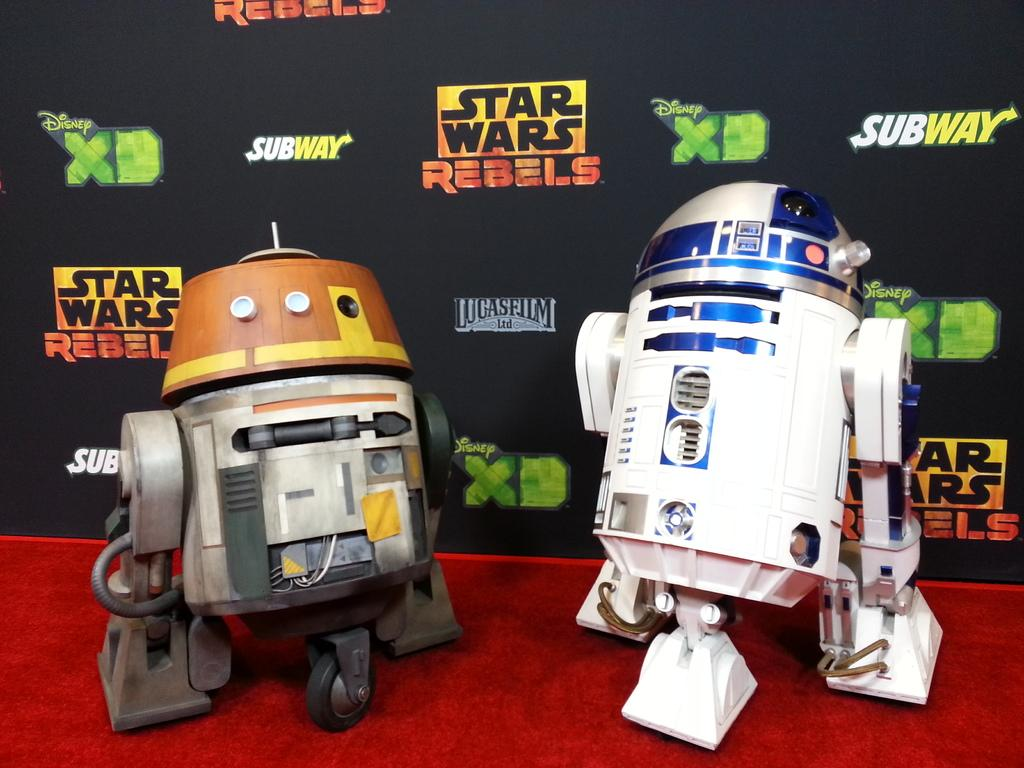What can be seen in the front of the image? There are machines in the front of the image. What is present in the background of the image? There is a banner with text in the background of the image. What is on the floor in the front of the image? There is a red color mat on the floor in the front of the image. Can you see a quill being used to write on the banner in the image? There is no quill present in the image, and the banner does not show any writing being done. Is there a bottle visible on the red mat in the front of the image? There is no bottle present on the red mat in the image. 